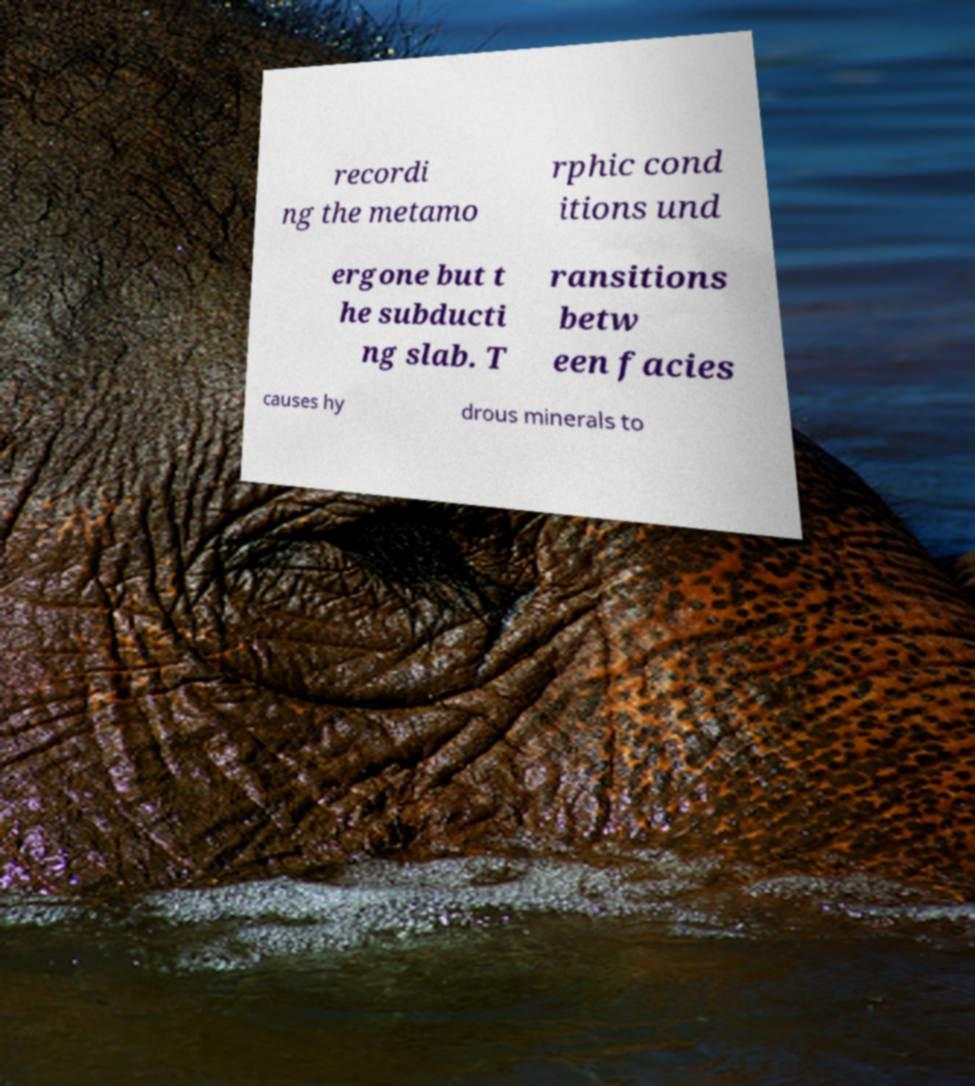Please identify and transcribe the text found in this image. recordi ng the metamo rphic cond itions und ergone but t he subducti ng slab. T ransitions betw een facies causes hy drous minerals to 